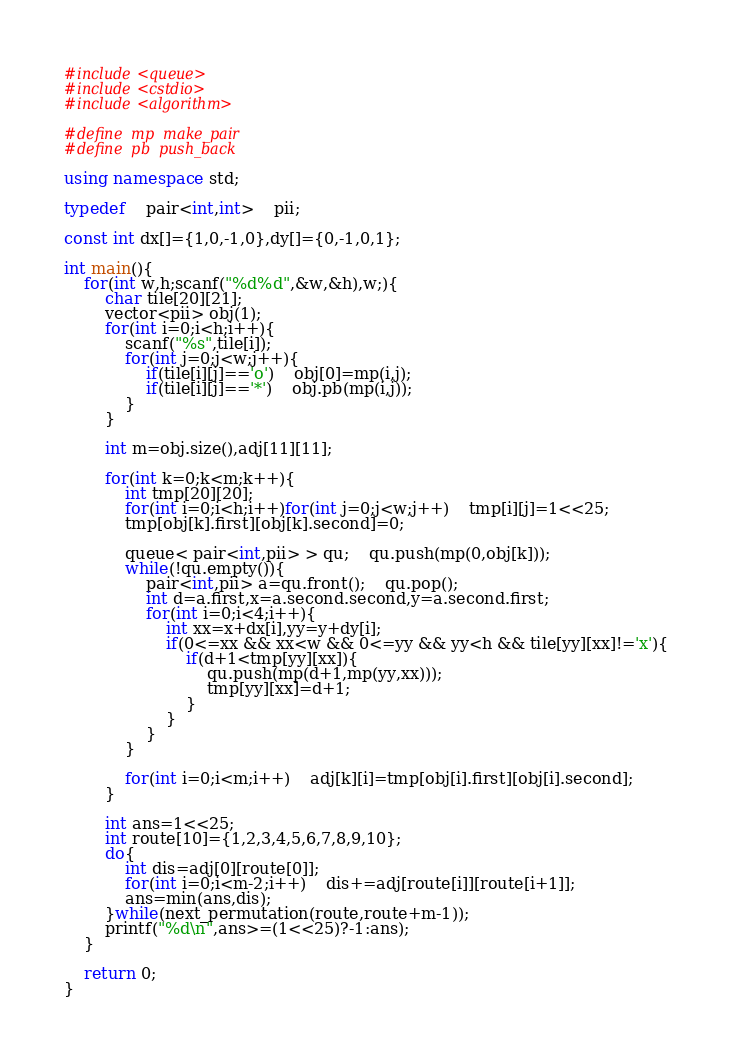<code> <loc_0><loc_0><loc_500><loc_500><_C++_>#include<queue>
#include<cstdio>
#include<algorithm>

#define	mp	make_pair
#define	pb	push_back

using namespace std;

typedef	pair<int,int>	pii;

const int dx[]={1,0,-1,0},dy[]={0,-1,0,1};

int main(){
	for(int w,h;scanf("%d%d",&w,&h),w;){
		char tile[20][21];
		vector<pii> obj(1);
		for(int i=0;i<h;i++){
			scanf("%s",tile[i]);
			for(int j=0;j<w;j++){
				if(tile[i][j]=='o')	obj[0]=mp(i,j);
				if(tile[i][j]=='*')	obj.pb(mp(i,j));
			}
		}

		int m=obj.size(),adj[11][11];

		for(int k=0;k<m;k++){
			int tmp[20][20];
			for(int i=0;i<h;i++)for(int j=0;j<w;j++)	tmp[i][j]=1<<25;
			tmp[obj[k].first][obj[k].second]=0;

			queue< pair<int,pii> > qu;	qu.push(mp(0,obj[k]));
			while(!qu.empty()){
				pair<int,pii> a=qu.front();	qu.pop();
				int d=a.first,x=a.second.second,y=a.second.first;
				for(int i=0;i<4;i++){
					int xx=x+dx[i],yy=y+dy[i];
					if(0<=xx && xx<w && 0<=yy && yy<h && tile[yy][xx]!='x'){
						if(d+1<tmp[yy][xx]){
							qu.push(mp(d+1,mp(yy,xx)));
							tmp[yy][xx]=d+1;
						}
					}
				}
			}

			for(int i=0;i<m;i++)	adj[k][i]=tmp[obj[i].first][obj[i].second];
		}

		int ans=1<<25;
		int route[10]={1,2,3,4,5,6,7,8,9,10};
		do{
			int dis=adj[0][route[0]];
			for(int i=0;i<m-2;i++)	dis+=adj[route[i]][route[i+1]];
			ans=min(ans,dis);
		}while(next_permutation(route,route+m-1));
		printf("%d\n",ans>=(1<<25)?-1:ans);
	}

	return 0;
}</code> 